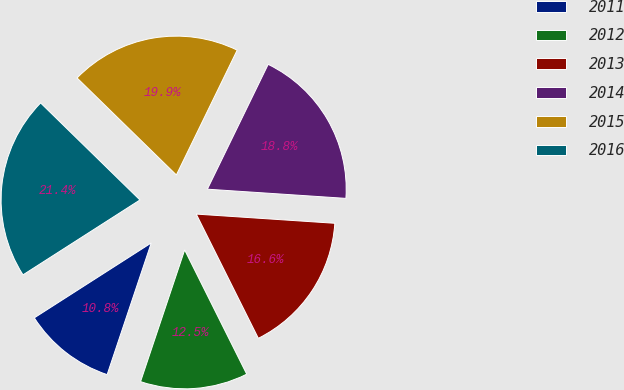Convert chart to OTSL. <chart><loc_0><loc_0><loc_500><loc_500><pie_chart><fcel>2011<fcel>2012<fcel>2013<fcel>2014<fcel>2015<fcel>2016<nl><fcel>10.79%<fcel>12.52%<fcel>16.57%<fcel>18.84%<fcel>19.9%<fcel>21.38%<nl></chart> 